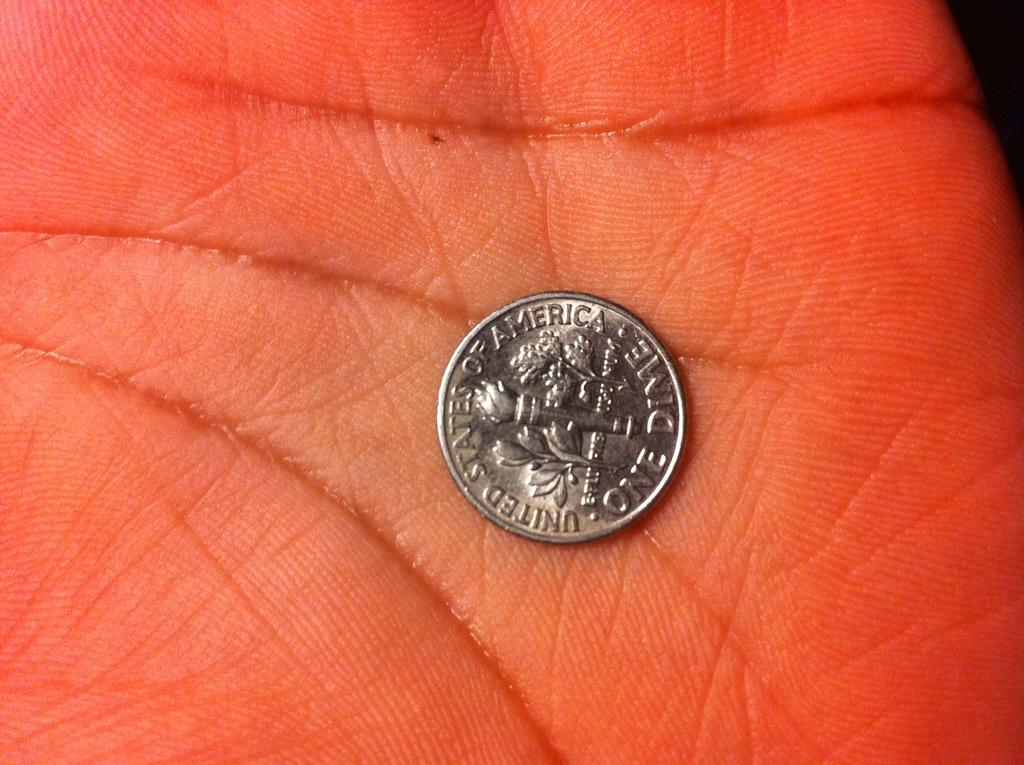<image>
Summarize the visual content of the image. A person has a dime in the palm of their hand that says United States of America One Dime. 